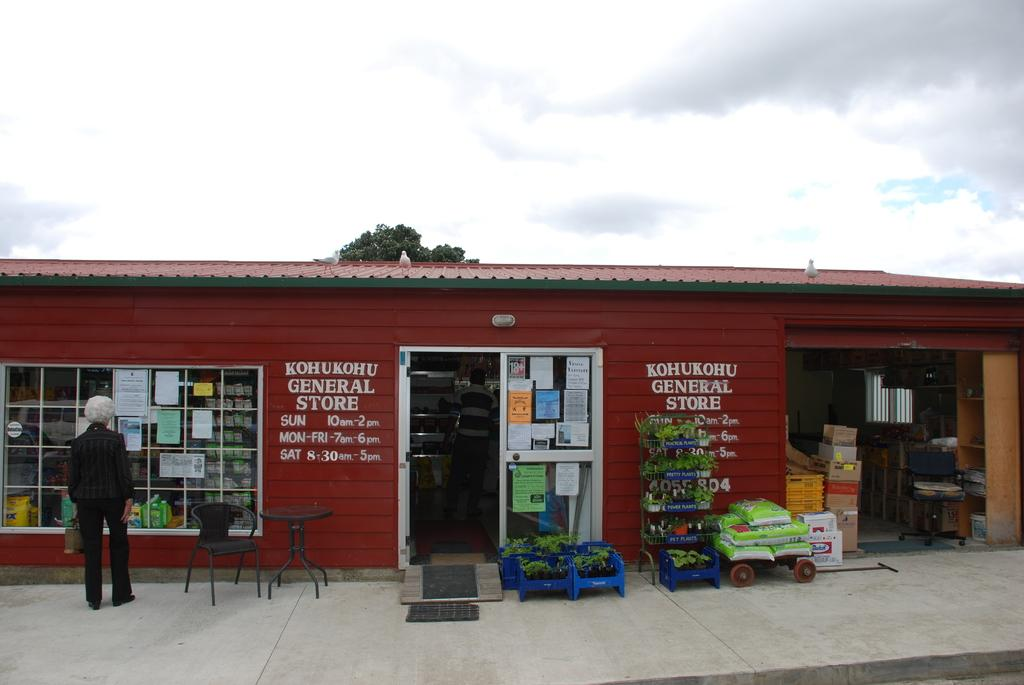Provide a one-sentence caption for the provided image. Kohukohu general store with a red roof and walls. 